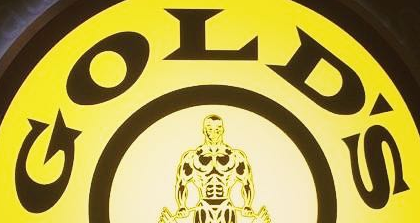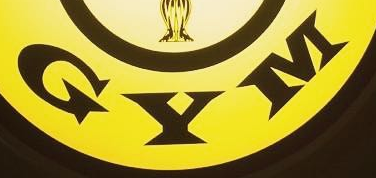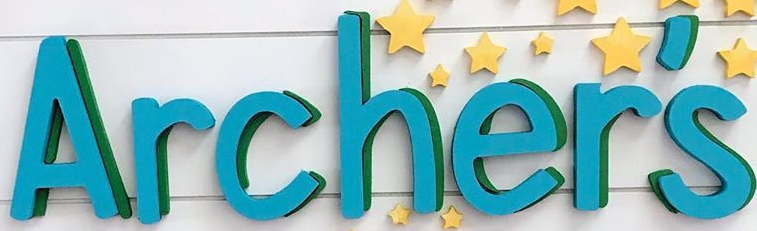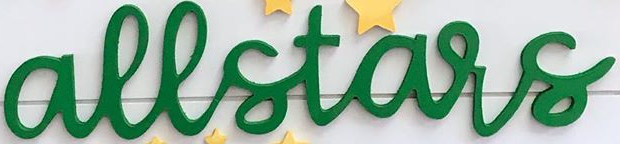What words are shown in these images in order, separated by a semicolon? GOLD'S; GYM; Archer's; allstars 